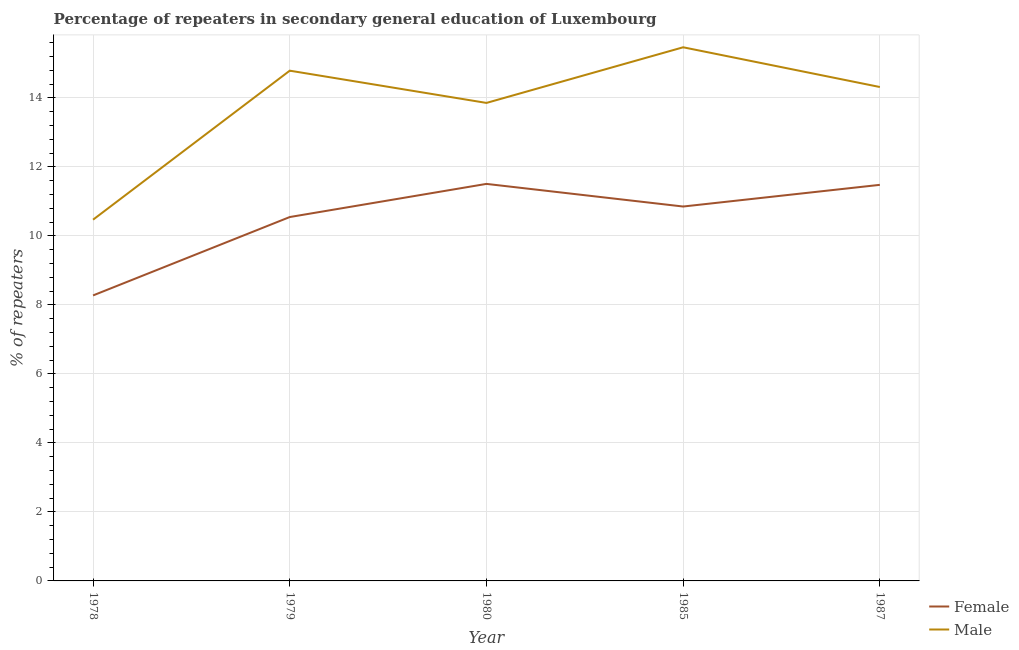What is the percentage of female repeaters in 1979?
Make the answer very short. 10.55. Across all years, what is the maximum percentage of female repeaters?
Provide a short and direct response. 11.51. Across all years, what is the minimum percentage of male repeaters?
Your response must be concise. 10.47. In which year was the percentage of male repeaters maximum?
Provide a succinct answer. 1985. In which year was the percentage of female repeaters minimum?
Give a very brief answer. 1978. What is the total percentage of male repeaters in the graph?
Your response must be concise. 68.91. What is the difference between the percentage of female repeaters in 1979 and that in 1980?
Ensure brevity in your answer.  -0.96. What is the difference between the percentage of male repeaters in 1980 and the percentage of female repeaters in 1979?
Offer a very short reply. 3.31. What is the average percentage of male repeaters per year?
Ensure brevity in your answer.  13.78. In the year 1979, what is the difference between the percentage of female repeaters and percentage of male repeaters?
Ensure brevity in your answer.  -4.24. What is the ratio of the percentage of female repeaters in 1978 to that in 1985?
Make the answer very short. 0.76. What is the difference between the highest and the second highest percentage of female repeaters?
Offer a terse response. 0.03. What is the difference between the highest and the lowest percentage of male repeaters?
Ensure brevity in your answer.  5. Is the sum of the percentage of male repeaters in 1978 and 1985 greater than the maximum percentage of female repeaters across all years?
Provide a short and direct response. Yes. Does the percentage of male repeaters monotonically increase over the years?
Provide a short and direct response. No. Is the percentage of female repeaters strictly greater than the percentage of male repeaters over the years?
Keep it short and to the point. No. Is the percentage of female repeaters strictly less than the percentage of male repeaters over the years?
Make the answer very short. Yes. How many years are there in the graph?
Provide a succinct answer. 5. Are the values on the major ticks of Y-axis written in scientific E-notation?
Your answer should be compact. No. Does the graph contain any zero values?
Keep it short and to the point. No. How are the legend labels stacked?
Offer a very short reply. Vertical. What is the title of the graph?
Keep it short and to the point. Percentage of repeaters in secondary general education of Luxembourg. Does "Working only" appear as one of the legend labels in the graph?
Keep it short and to the point. No. What is the label or title of the Y-axis?
Make the answer very short. % of repeaters. What is the % of repeaters in Female in 1978?
Offer a terse response. 8.28. What is the % of repeaters of Male in 1978?
Ensure brevity in your answer.  10.47. What is the % of repeaters in Female in 1979?
Offer a very short reply. 10.55. What is the % of repeaters of Male in 1979?
Give a very brief answer. 14.79. What is the % of repeaters in Female in 1980?
Provide a succinct answer. 11.51. What is the % of repeaters of Male in 1980?
Offer a terse response. 13.86. What is the % of repeaters in Female in 1985?
Keep it short and to the point. 10.85. What is the % of repeaters in Male in 1985?
Give a very brief answer. 15.47. What is the % of repeaters in Female in 1987?
Make the answer very short. 11.48. What is the % of repeaters in Male in 1987?
Ensure brevity in your answer.  14.32. Across all years, what is the maximum % of repeaters of Female?
Your answer should be very brief. 11.51. Across all years, what is the maximum % of repeaters of Male?
Offer a terse response. 15.47. Across all years, what is the minimum % of repeaters of Female?
Keep it short and to the point. 8.28. Across all years, what is the minimum % of repeaters of Male?
Give a very brief answer. 10.47. What is the total % of repeaters in Female in the graph?
Offer a very short reply. 52.67. What is the total % of repeaters of Male in the graph?
Make the answer very short. 68.91. What is the difference between the % of repeaters in Female in 1978 and that in 1979?
Make the answer very short. -2.27. What is the difference between the % of repeaters in Male in 1978 and that in 1979?
Provide a succinct answer. -4.32. What is the difference between the % of repeaters of Female in 1978 and that in 1980?
Give a very brief answer. -3.23. What is the difference between the % of repeaters in Male in 1978 and that in 1980?
Your answer should be very brief. -3.39. What is the difference between the % of repeaters in Female in 1978 and that in 1985?
Offer a very short reply. -2.58. What is the difference between the % of repeaters of Male in 1978 and that in 1985?
Offer a terse response. -5. What is the difference between the % of repeaters of Female in 1978 and that in 1987?
Offer a very short reply. -3.21. What is the difference between the % of repeaters in Male in 1978 and that in 1987?
Your answer should be very brief. -3.85. What is the difference between the % of repeaters in Female in 1979 and that in 1980?
Make the answer very short. -0.96. What is the difference between the % of repeaters of Male in 1979 and that in 1980?
Make the answer very short. 0.94. What is the difference between the % of repeaters in Female in 1979 and that in 1985?
Your answer should be compact. -0.3. What is the difference between the % of repeaters in Male in 1979 and that in 1985?
Your response must be concise. -0.68. What is the difference between the % of repeaters of Female in 1979 and that in 1987?
Your response must be concise. -0.93. What is the difference between the % of repeaters in Male in 1979 and that in 1987?
Offer a terse response. 0.47. What is the difference between the % of repeaters of Female in 1980 and that in 1985?
Make the answer very short. 0.66. What is the difference between the % of repeaters of Male in 1980 and that in 1985?
Give a very brief answer. -1.61. What is the difference between the % of repeaters of Female in 1980 and that in 1987?
Keep it short and to the point. 0.03. What is the difference between the % of repeaters of Male in 1980 and that in 1987?
Your answer should be compact. -0.46. What is the difference between the % of repeaters of Female in 1985 and that in 1987?
Provide a short and direct response. -0.63. What is the difference between the % of repeaters of Male in 1985 and that in 1987?
Provide a succinct answer. 1.15. What is the difference between the % of repeaters of Female in 1978 and the % of repeaters of Male in 1979?
Provide a short and direct response. -6.52. What is the difference between the % of repeaters of Female in 1978 and the % of repeaters of Male in 1980?
Your response must be concise. -5.58. What is the difference between the % of repeaters in Female in 1978 and the % of repeaters in Male in 1985?
Keep it short and to the point. -7.19. What is the difference between the % of repeaters of Female in 1978 and the % of repeaters of Male in 1987?
Your answer should be very brief. -6.04. What is the difference between the % of repeaters in Female in 1979 and the % of repeaters in Male in 1980?
Your answer should be very brief. -3.31. What is the difference between the % of repeaters in Female in 1979 and the % of repeaters in Male in 1985?
Give a very brief answer. -4.92. What is the difference between the % of repeaters in Female in 1979 and the % of repeaters in Male in 1987?
Provide a short and direct response. -3.77. What is the difference between the % of repeaters in Female in 1980 and the % of repeaters in Male in 1985?
Give a very brief answer. -3.96. What is the difference between the % of repeaters of Female in 1980 and the % of repeaters of Male in 1987?
Your response must be concise. -2.81. What is the difference between the % of repeaters in Female in 1985 and the % of repeaters in Male in 1987?
Keep it short and to the point. -3.46. What is the average % of repeaters of Female per year?
Keep it short and to the point. 10.53. What is the average % of repeaters of Male per year?
Make the answer very short. 13.78. In the year 1978, what is the difference between the % of repeaters in Female and % of repeaters in Male?
Offer a very short reply. -2.2. In the year 1979, what is the difference between the % of repeaters of Female and % of repeaters of Male?
Ensure brevity in your answer.  -4.24. In the year 1980, what is the difference between the % of repeaters of Female and % of repeaters of Male?
Offer a terse response. -2.35. In the year 1985, what is the difference between the % of repeaters of Female and % of repeaters of Male?
Offer a very short reply. -4.62. In the year 1987, what is the difference between the % of repeaters of Female and % of repeaters of Male?
Keep it short and to the point. -2.84. What is the ratio of the % of repeaters in Female in 1978 to that in 1979?
Provide a short and direct response. 0.78. What is the ratio of the % of repeaters in Male in 1978 to that in 1979?
Ensure brevity in your answer.  0.71. What is the ratio of the % of repeaters of Female in 1978 to that in 1980?
Ensure brevity in your answer.  0.72. What is the ratio of the % of repeaters of Male in 1978 to that in 1980?
Offer a very short reply. 0.76. What is the ratio of the % of repeaters of Female in 1978 to that in 1985?
Your answer should be very brief. 0.76. What is the ratio of the % of repeaters of Male in 1978 to that in 1985?
Ensure brevity in your answer.  0.68. What is the ratio of the % of repeaters of Female in 1978 to that in 1987?
Ensure brevity in your answer.  0.72. What is the ratio of the % of repeaters in Male in 1978 to that in 1987?
Provide a succinct answer. 0.73. What is the ratio of the % of repeaters of Female in 1979 to that in 1980?
Give a very brief answer. 0.92. What is the ratio of the % of repeaters of Male in 1979 to that in 1980?
Ensure brevity in your answer.  1.07. What is the ratio of the % of repeaters of Female in 1979 to that in 1985?
Your answer should be very brief. 0.97. What is the ratio of the % of repeaters of Male in 1979 to that in 1985?
Your answer should be compact. 0.96. What is the ratio of the % of repeaters in Female in 1979 to that in 1987?
Provide a short and direct response. 0.92. What is the ratio of the % of repeaters of Male in 1979 to that in 1987?
Your response must be concise. 1.03. What is the ratio of the % of repeaters of Female in 1980 to that in 1985?
Provide a succinct answer. 1.06. What is the ratio of the % of repeaters of Male in 1980 to that in 1985?
Ensure brevity in your answer.  0.9. What is the ratio of the % of repeaters of Male in 1980 to that in 1987?
Your response must be concise. 0.97. What is the ratio of the % of repeaters of Female in 1985 to that in 1987?
Your answer should be compact. 0.95. What is the ratio of the % of repeaters in Male in 1985 to that in 1987?
Provide a short and direct response. 1.08. What is the difference between the highest and the second highest % of repeaters of Female?
Keep it short and to the point. 0.03. What is the difference between the highest and the second highest % of repeaters of Male?
Offer a terse response. 0.68. What is the difference between the highest and the lowest % of repeaters of Female?
Keep it short and to the point. 3.23. What is the difference between the highest and the lowest % of repeaters in Male?
Make the answer very short. 5. 